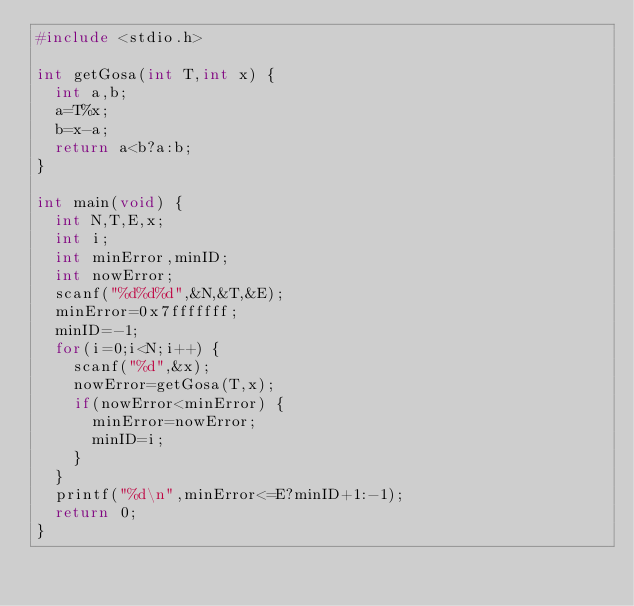Convert code to text. <code><loc_0><loc_0><loc_500><loc_500><_C_>#include <stdio.h>

int getGosa(int T,int x) {
	int a,b;
	a=T%x;
	b=x-a;
	return a<b?a:b;
}

int main(void) {
	int N,T,E,x;
	int i;
	int minError,minID;
	int nowError;
	scanf("%d%d%d",&N,&T,&E);
	minError=0x7fffffff;
	minID=-1;
	for(i=0;i<N;i++) {
		scanf("%d",&x);
		nowError=getGosa(T,x);
		if(nowError<minError) {
			minError=nowError;
			minID=i;
		}
	}
	printf("%d\n",minError<=E?minID+1:-1);
	return 0;
}</code> 